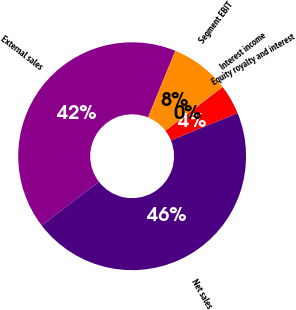<chart> <loc_0><loc_0><loc_500><loc_500><pie_chart><fcel>External sales<fcel>Net sales<fcel>Equity royalty and interest<fcel>Interest income<fcel>Segment EBIT<nl><fcel>41.6%<fcel>45.77%<fcel>4.21%<fcel>0.04%<fcel>8.38%<nl></chart> 